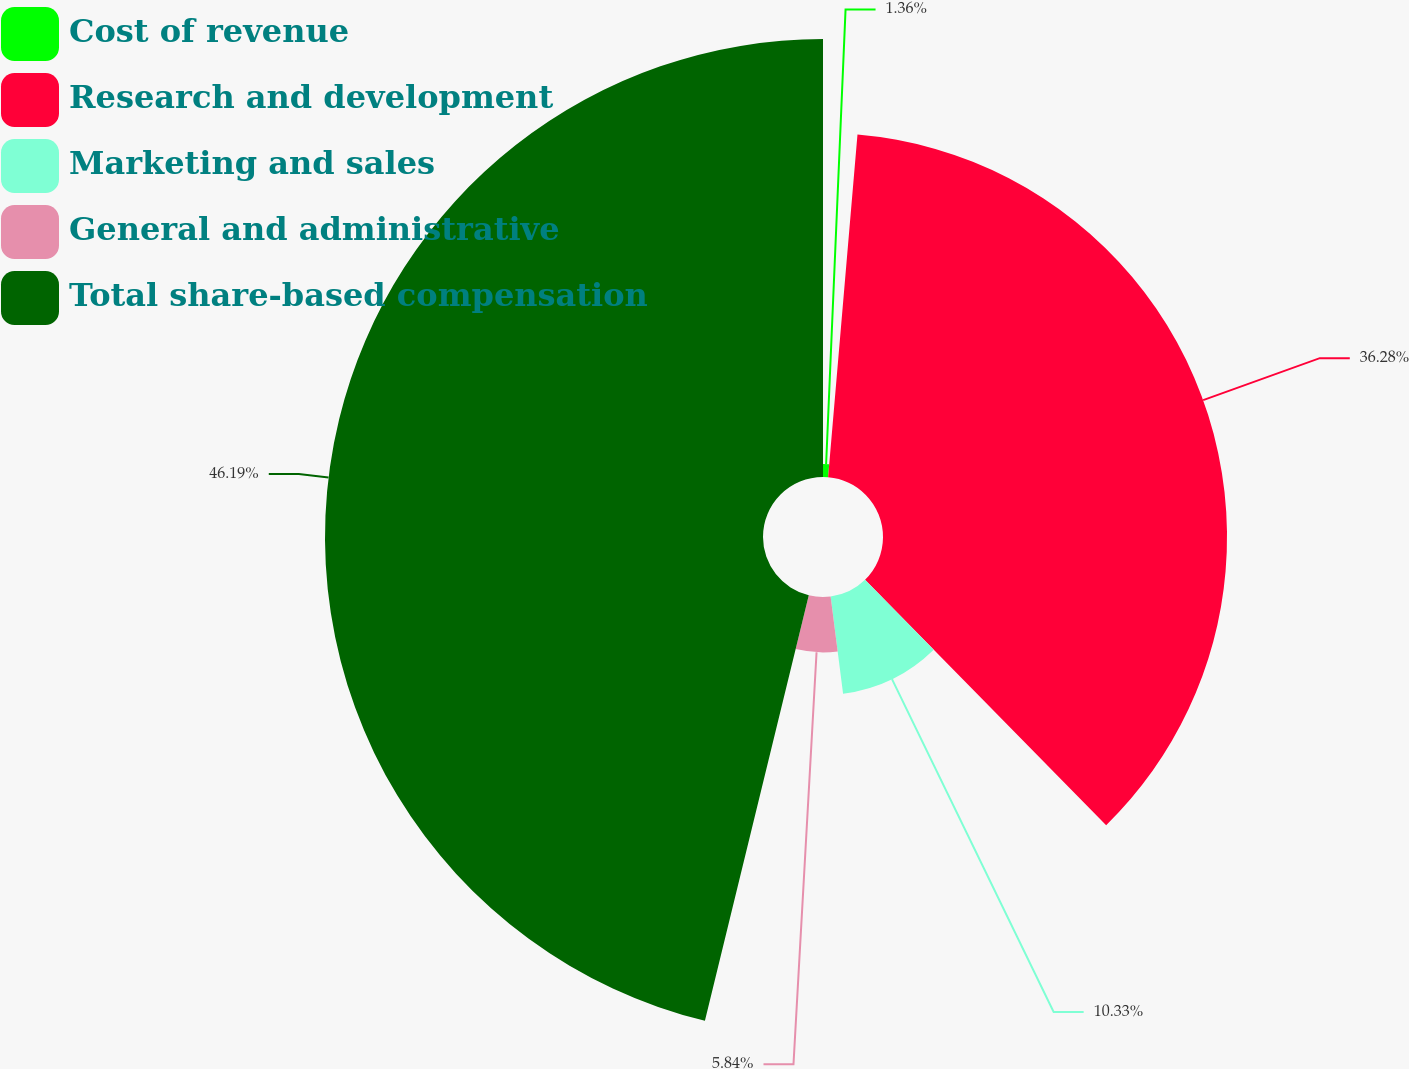Convert chart to OTSL. <chart><loc_0><loc_0><loc_500><loc_500><pie_chart><fcel>Cost of revenue<fcel>Research and development<fcel>Marketing and sales<fcel>General and administrative<fcel>Total share-based compensation<nl><fcel>1.36%<fcel>36.28%<fcel>10.33%<fcel>5.84%<fcel>46.19%<nl></chart> 